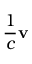Convert formula to latex. <formula><loc_0><loc_0><loc_500><loc_500>{ \frac { 1 } { c } } v</formula> 